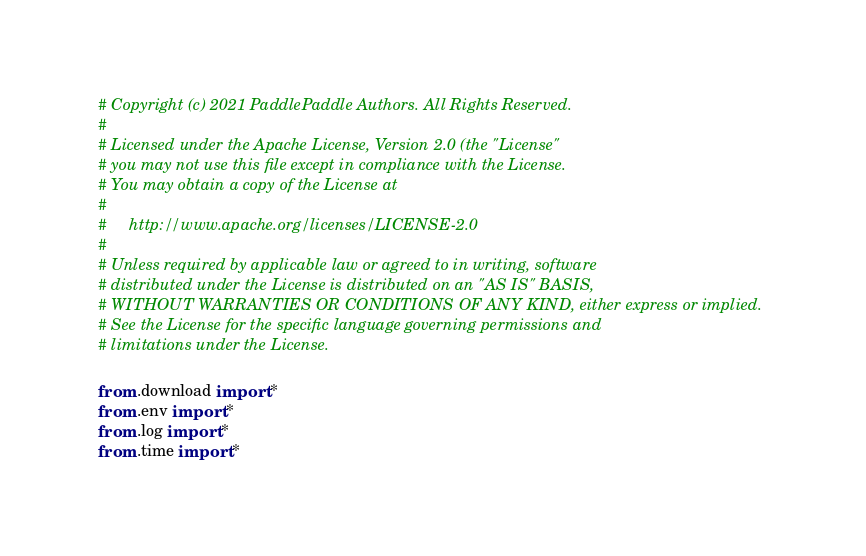<code> <loc_0><loc_0><loc_500><loc_500><_Python_># Copyright (c) 2021 PaddlePaddle Authors. All Rights Reserved.
#
# Licensed under the Apache License, Version 2.0 (the "License"
# you may not use this file except in compliance with the License.
# You may obtain a copy of the License at
#
#     http://www.apache.org/licenses/LICENSE-2.0
#
# Unless required by applicable law or agreed to in writing, software
# distributed under the License is distributed on an "AS IS" BASIS,
# WITHOUT WARRANTIES OR CONDITIONS OF ANY KIND, either express or implied.
# See the License for the specific language governing permissions and
# limitations under the License.

from .download import *
from .env import *
from .log import *
from .time import *
</code> 